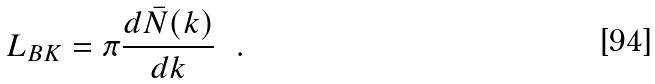<formula> <loc_0><loc_0><loc_500><loc_500>L _ { B K } = \pi \frac { d \bar { N } ( k ) } { d k } \ \ .</formula> 